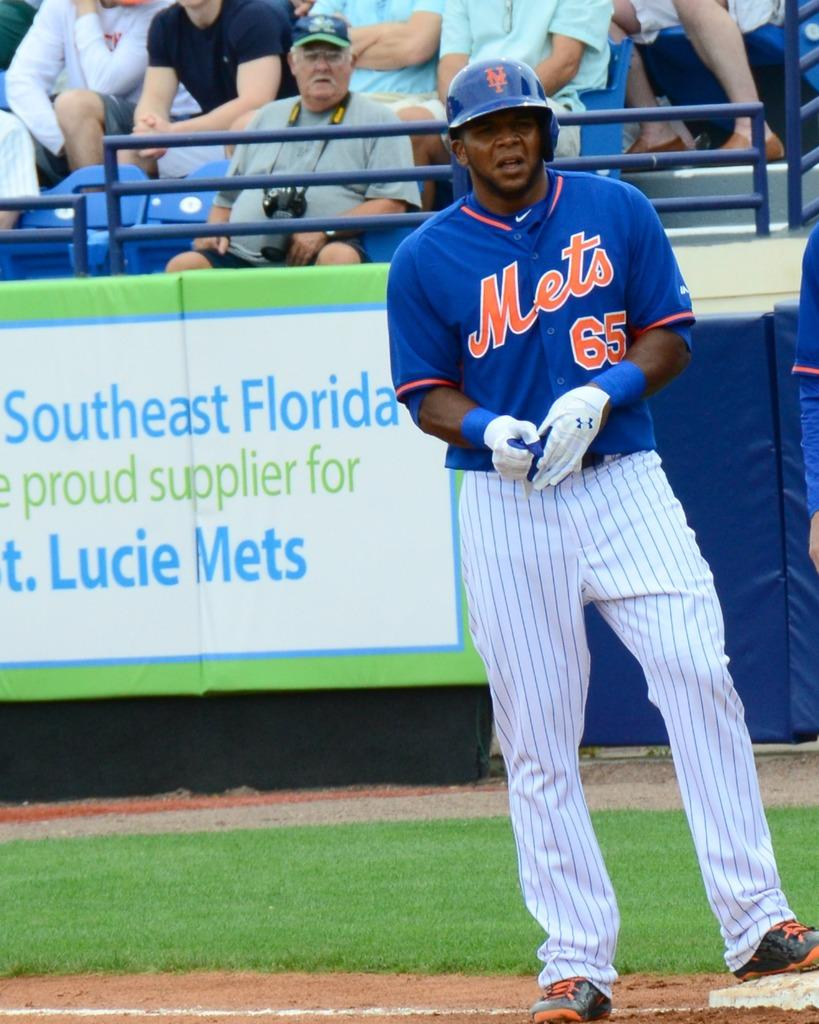What is the main subject of the image? The main subject of the image is a player standing on the ground. What is located behind the player? There is a banner behind the player. What can be seen beyond the banner? There are spectators behind the banner. What type of weather can be seen in the image? The provided facts do not mention any weather conditions, so it cannot be determined from the image. 